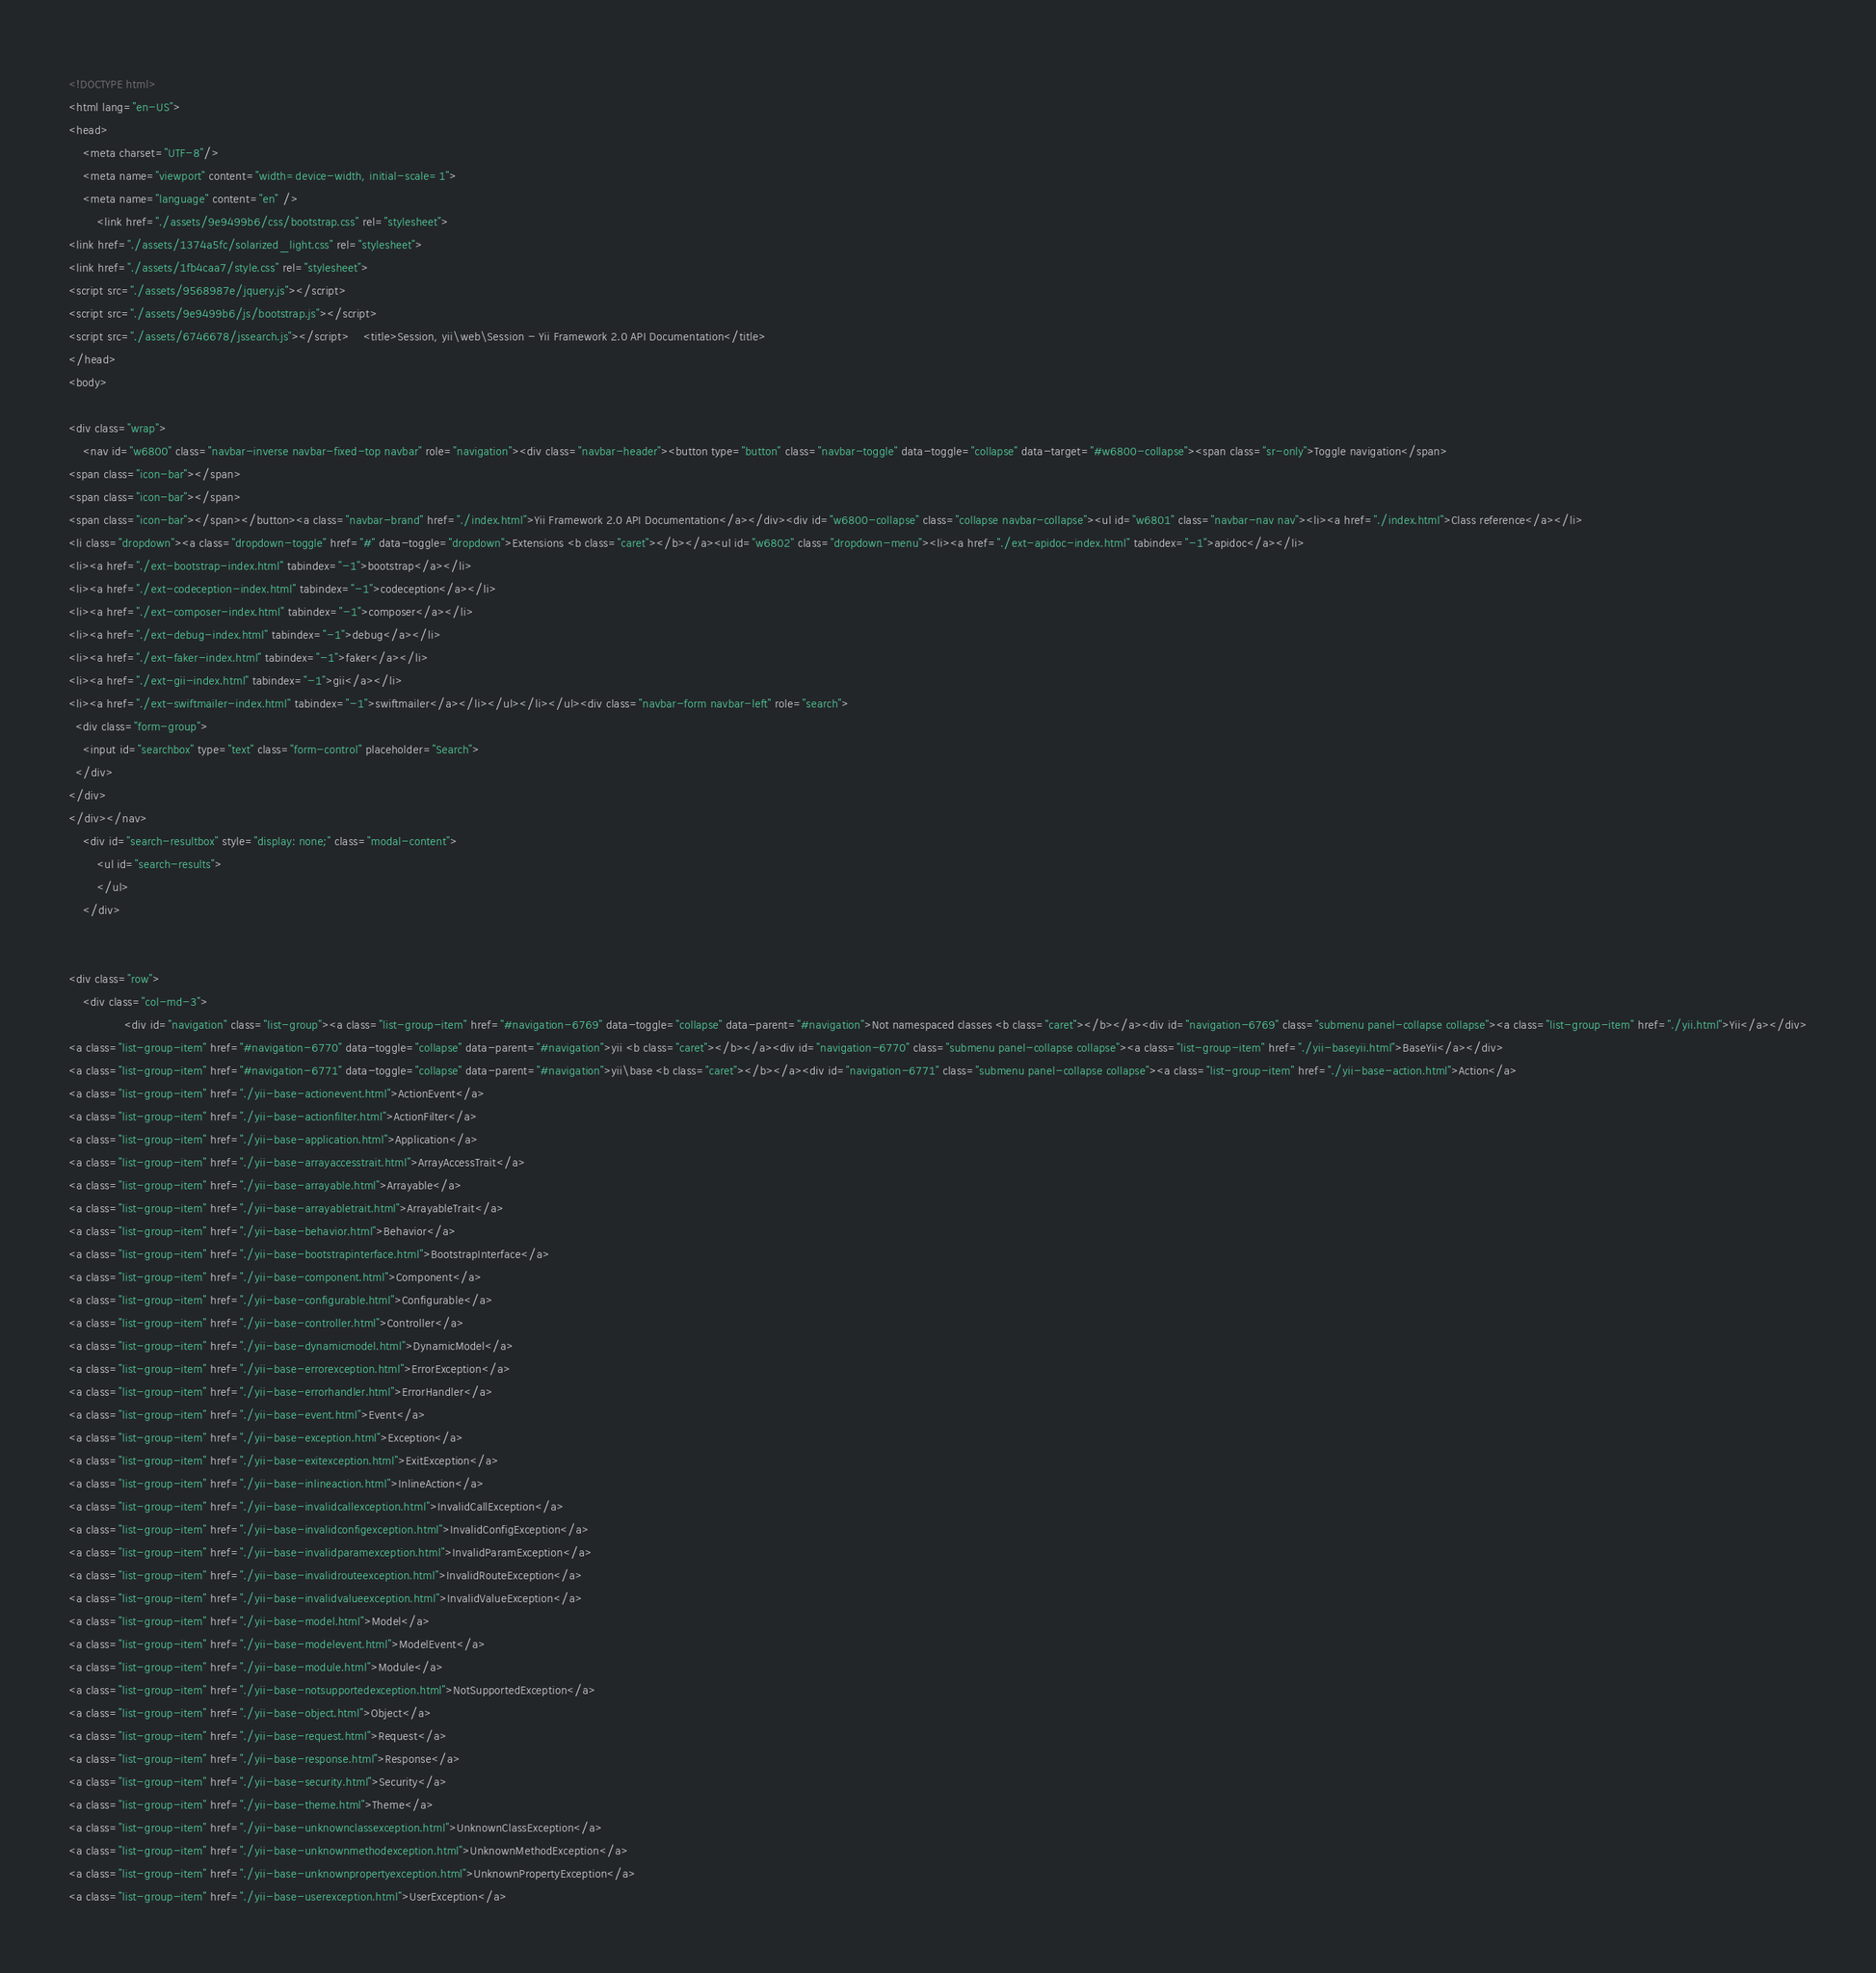<code> <loc_0><loc_0><loc_500><loc_500><_HTML_><!DOCTYPE html>
<html lang="en-US">
<head>
    <meta charset="UTF-8"/>
    <meta name="viewport" content="width=device-width, initial-scale=1">
    <meta name="language" content="en" />
        <link href="./assets/9e9499b6/css/bootstrap.css" rel="stylesheet">
<link href="./assets/1374a5fc/solarized_light.css" rel="stylesheet">
<link href="./assets/1fb4caa7/style.css" rel="stylesheet">
<script src="./assets/9568987e/jquery.js"></script>
<script src="./assets/9e9499b6/js/bootstrap.js"></script>
<script src="./assets/6746678/jssearch.js"></script>    <title>Session, yii\web\Session - Yii Framework 2.0 API Documentation</title>
</head>
<body>

<div class="wrap">
    <nav id="w6800" class="navbar-inverse navbar-fixed-top navbar" role="navigation"><div class="navbar-header"><button type="button" class="navbar-toggle" data-toggle="collapse" data-target="#w6800-collapse"><span class="sr-only">Toggle navigation</span>
<span class="icon-bar"></span>
<span class="icon-bar"></span>
<span class="icon-bar"></span></button><a class="navbar-brand" href="./index.html">Yii Framework 2.0 API Documentation</a></div><div id="w6800-collapse" class="collapse navbar-collapse"><ul id="w6801" class="navbar-nav nav"><li><a href="./index.html">Class reference</a></li>
<li class="dropdown"><a class="dropdown-toggle" href="#" data-toggle="dropdown">Extensions <b class="caret"></b></a><ul id="w6802" class="dropdown-menu"><li><a href="./ext-apidoc-index.html" tabindex="-1">apidoc</a></li>
<li><a href="./ext-bootstrap-index.html" tabindex="-1">bootstrap</a></li>
<li><a href="./ext-codeception-index.html" tabindex="-1">codeception</a></li>
<li><a href="./ext-composer-index.html" tabindex="-1">composer</a></li>
<li><a href="./ext-debug-index.html" tabindex="-1">debug</a></li>
<li><a href="./ext-faker-index.html" tabindex="-1">faker</a></li>
<li><a href="./ext-gii-index.html" tabindex="-1">gii</a></li>
<li><a href="./ext-swiftmailer-index.html" tabindex="-1">swiftmailer</a></li></ul></li></ul><div class="navbar-form navbar-left" role="search">
  <div class="form-group">
    <input id="searchbox" type="text" class="form-control" placeholder="Search">
  </div>
</div>
</div></nav>
    <div id="search-resultbox" style="display: none;" class="modal-content">
        <ul id="search-results">
        </ul>
    </div>

    
<div class="row">
    <div class="col-md-3">
                <div id="navigation" class="list-group"><a class="list-group-item" href="#navigation-6769" data-toggle="collapse" data-parent="#navigation">Not namespaced classes <b class="caret"></b></a><div id="navigation-6769" class="submenu panel-collapse collapse"><a class="list-group-item" href="./yii.html">Yii</a></div>
<a class="list-group-item" href="#navigation-6770" data-toggle="collapse" data-parent="#navigation">yii <b class="caret"></b></a><div id="navigation-6770" class="submenu panel-collapse collapse"><a class="list-group-item" href="./yii-baseyii.html">BaseYii</a></div>
<a class="list-group-item" href="#navigation-6771" data-toggle="collapse" data-parent="#navigation">yii\base <b class="caret"></b></a><div id="navigation-6771" class="submenu panel-collapse collapse"><a class="list-group-item" href="./yii-base-action.html">Action</a>
<a class="list-group-item" href="./yii-base-actionevent.html">ActionEvent</a>
<a class="list-group-item" href="./yii-base-actionfilter.html">ActionFilter</a>
<a class="list-group-item" href="./yii-base-application.html">Application</a>
<a class="list-group-item" href="./yii-base-arrayaccesstrait.html">ArrayAccessTrait</a>
<a class="list-group-item" href="./yii-base-arrayable.html">Arrayable</a>
<a class="list-group-item" href="./yii-base-arrayabletrait.html">ArrayableTrait</a>
<a class="list-group-item" href="./yii-base-behavior.html">Behavior</a>
<a class="list-group-item" href="./yii-base-bootstrapinterface.html">BootstrapInterface</a>
<a class="list-group-item" href="./yii-base-component.html">Component</a>
<a class="list-group-item" href="./yii-base-configurable.html">Configurable</a>
<a class="list-group-item" href="./yii-base-controller.html">Controller</a>
<a class="list-group-item" href="./yii-base-dynamicmodel.html">DynamicModel</a>
<a class="list-group-item" href="./yii-base-errorexception.html">ErrorException</a>
<a class="list-group-item" href="./yii-base-errorhandler.html">ErrorHandler</a>
<a class="list-group-item" href="./yii-base-event.html">Event</a>
<a class="list-group-item" href="./yii-base-exception.html">Exception</a>
<a class="list-group-item" href="./yii-base-exitexception.html">ExitException</a>
<a class="list-group-item" href="./yii-base-inlineaction.html">InlineAction</a>
<a class="list-group-item" href="./yii-base-invalidcallexception.html">InvalidCallException</a>
<a class="list-group-item" href="./yii-base-invalidconfigexception.html">InvalidConfigException</a>
<a class="list-group-item" href="./yii-base-invalidparamexception.html">InvalidParamException</a>
<a class="list-group-item" href="./yii-base-invalidrouteexception.html">InvalidRouteException</a>
<a class="list-group-item" href="./yii-base-invalidvalueexception.html">InvalidValueException</a>
<a class="list-group-item" href="./yii-base-model.html">Model</a>
<a class="list-group-item" href="./yii-base-modelevent.html">ModelEvent</a>
<a class="list-group-item" href="./yii-base-module.html">Module</a>
<a class="list-group-item" href="./yii-base-notsupportedexception.html">NotSupportedException</a>
<a class="list-group-item" href="./yii-base-object.html">Object</a>
<a class="list-group-item" href="./yii-base-request.html">Request</a>
<a class="list-group-item" href="./yii-base-response.html">Response</a>
<a class="list-group-item" href="./yii-base-security.html">Security</a>
<a class="list-group-item" href="./yii-base-theme.html">Theme</a>
<a class="list-group-item" href="./yii-base-unknownclassexception.html">UnknownClassException</a>
<a class="list-group-item" href="./yii-base-unknownmethodexception.html">UnknownMethodException</a>
<a class="list-group-item" href="./yii-base-unknownpropertyexception.html">UnknownPropertyException</a>
<a class="list-group-item" href="./yii-base-userexception.html">UserException</a></code> 